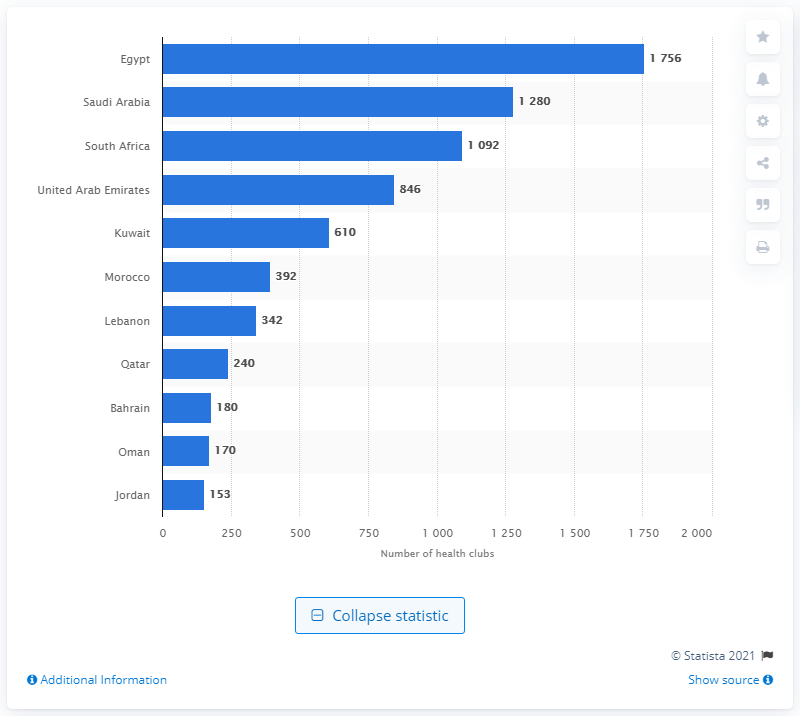Indicate a few pertinent items in this graphic. In 2019, the number of health and fitness clubs in Kuwait was reported to be 610. 